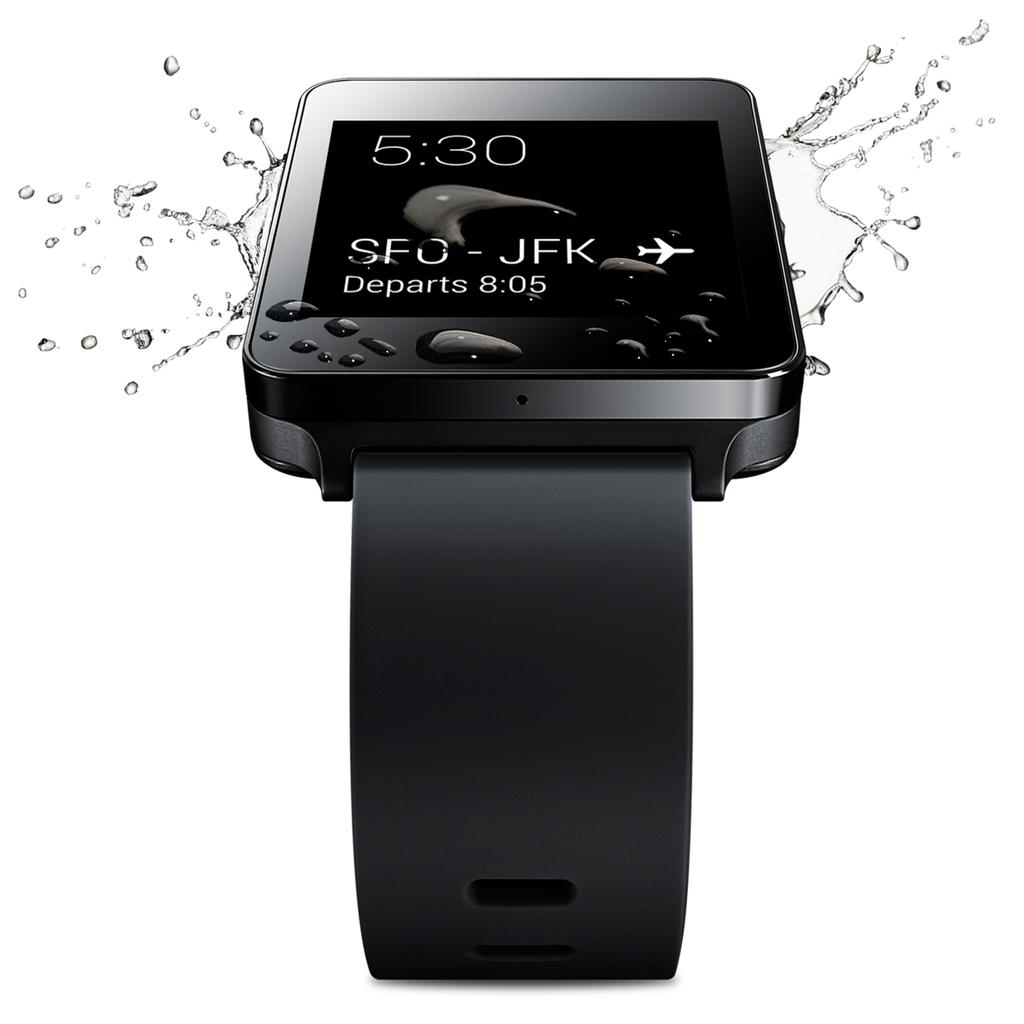<image>
Share a concise interpretation of the image provided. Advertisement for a new smart watch showing the time is 5:30. 